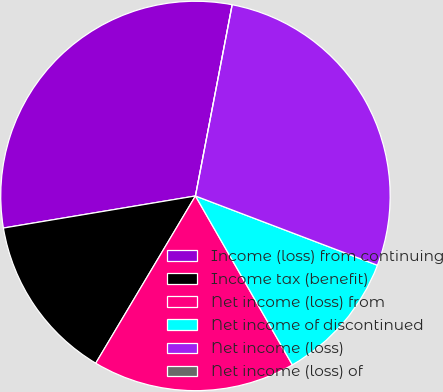<chart> <loc_0><loc_0><loc_500><loc_500><pie_chart><fcel>Income (loss) from continuing<fcel>Income tax (benefit)<fcel>Net income (loss) from<fcel>Net income of discontinued<fcel>Net income (loss)<fcel>Net income (loss) of<nl><fcel>30.66%<fcel>13.81%<fcel>16.85%<fcel>10.92%<fcel>27.77%<fcel>0.0%<nl></chart> 